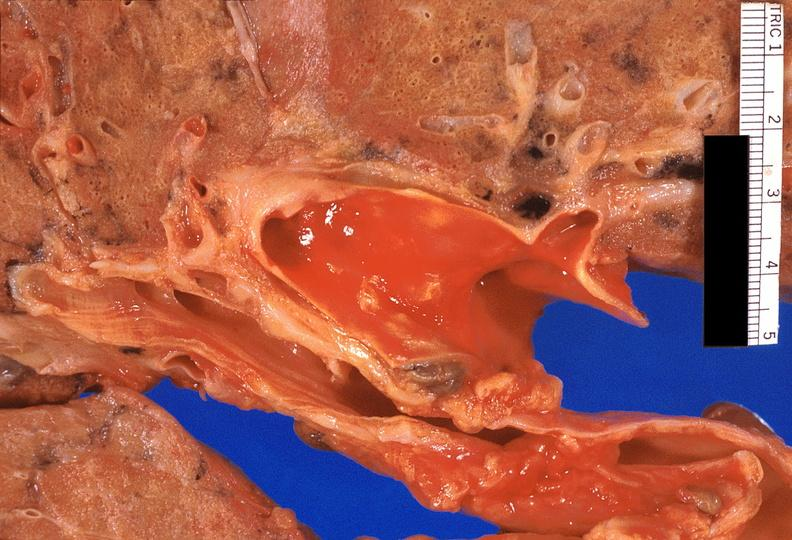what is present?
Answer the question using a single word or phrase. Respiratory 